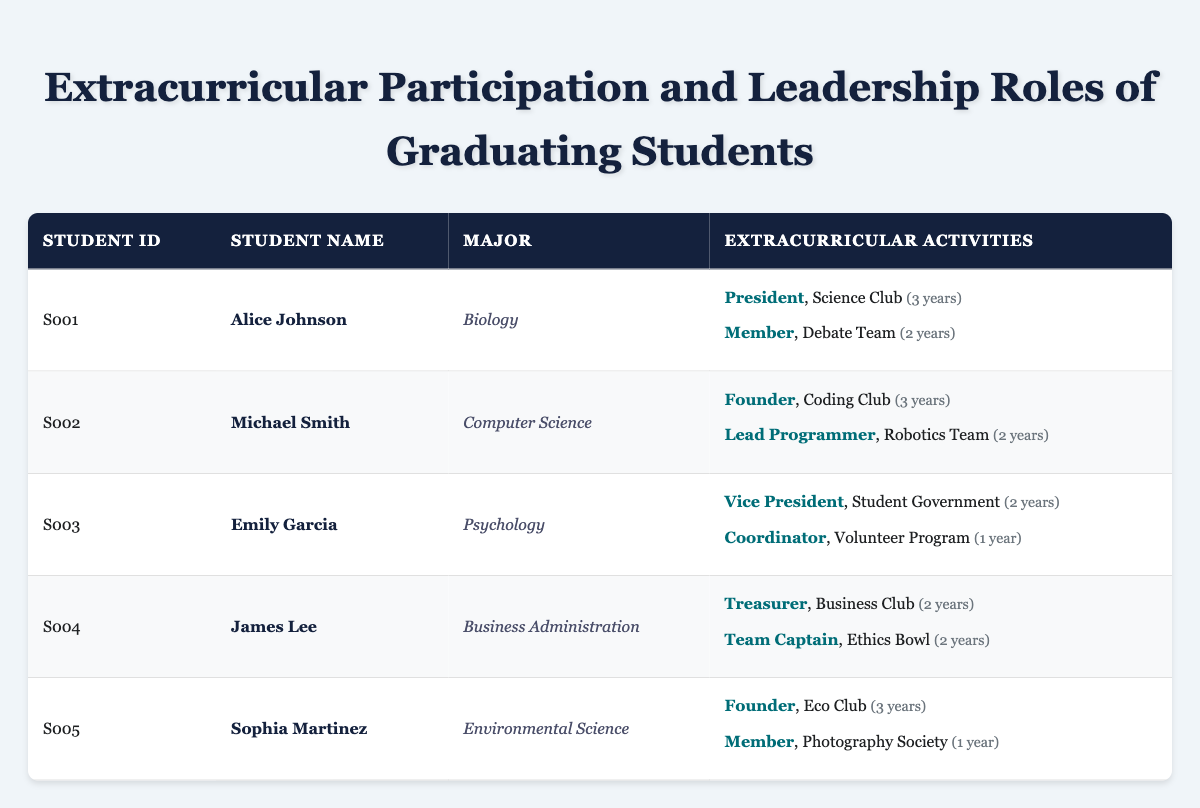What is the major of Alice Johnson? Alice Johnson is listed in the table with the Major column specified. Her major is directly under her name.
Answer: Biology How many years did Michael Smith participate in the Coding Club? Michael Smith is listed in the table alongside his extracurricular activities. Under the Coding Club, it states he was active for 3 years.
Answer: 3 years Which student held the role of Vice President in Extracurricular Activities? The table indicates the roles for each student. By examining the entries, Emily Garcia is mentioned as the Vice President of the Student Government.
Answer: Emily Garcia How many total years of participation does Sophia Martinez have across her activities? Sophia Martinez has 3 years in the Eco Club and 1 year in the Photography Society. Adding these together gives a total of 4 years.
Answer: 4 years Did James Lee have any roles related to leadership in his extracurricular activities? By reviewing James Lee's activities listed in the table, he served as both the Treasurer of the Business Club and Team Captain of the Ethics Bowl, which are leadership positions. Therefore, the answer is yes.
Answer: Yes Which student has the most years of experience in extracurricular activities? We need to evaluate the total years for each student. Alice Johnson has 5, Michael Smith has 5, Emily Garcia has 3, James Lee has 4, and Sophia Martinez has 4. Both Alice Johnson and Michael Smith have the highest total.
Answer: Alice Johnson and Michael Smith What is the role of Emily Garcia in the Volunteer Program? Assessing Emily Garcia's activities, she is listed as the Coordinator for the Volunteer Program which is explicitly mentioned in the table.
Answer: Coordinator Are there any students who founded their extracurricular activities? We need to look for roles labeled as "Founder" in the table. Sophia Martinez founded the Eco Club and Michael Smith founded the Coding Club, which confirms the existence of founders among students.
Answer: Yes What is the total number of students that participated in the Ethics Bowl? The only student listed for the Ethics Bowl is James Lee who served as Team Captain. Therefore, the total number is just one student.
Answer: 1 student 